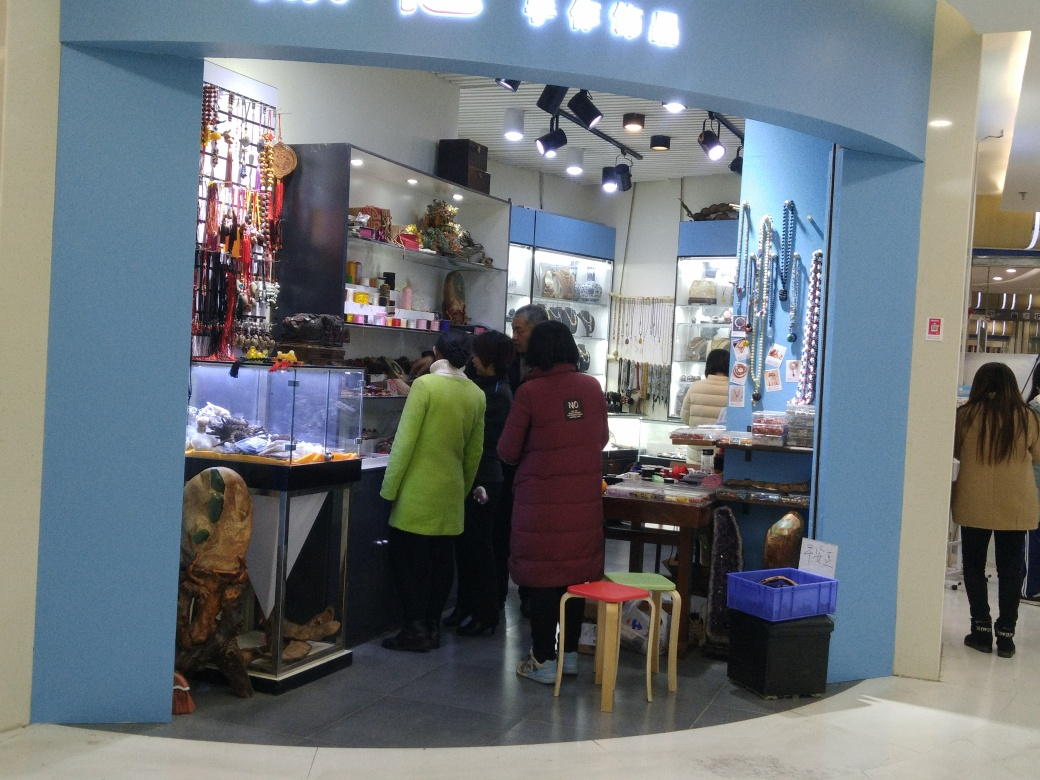What types of items are being sold at this shop? The shop appears to specialize in a variety of items, including jewelry, cultural ornaments, and potentially other handcrafted goods typically associated with artisanal markets or souvenir shops. 